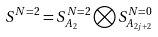<formula> <loc_0><loc_0><loc_500><loc_500>S ^ { N = 2 } = S _ { A _ { 2 } } ^ { N = 2 } \bigotimes S _ { A _ { 2 j + 2 } } ^ { N = 0 }</formula> 